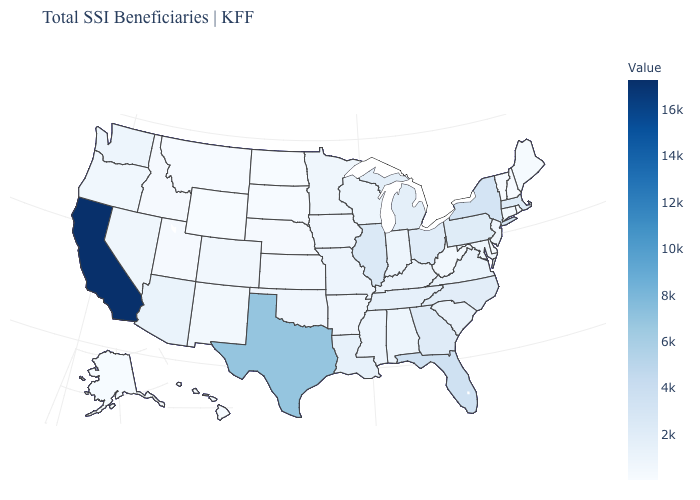Which states hav the highest value in the Northeast?
Answer briefly. New York. Does the map have missing data?
Concise answer only. No. Among the states that border Illinois , which have the lowest value?
Quick response, please. Iowa. Does Kansas have the lowest value in the MidWest?
Be succinct. No. Which states hav the highest value in the South?
Keep it brief. Texas. 